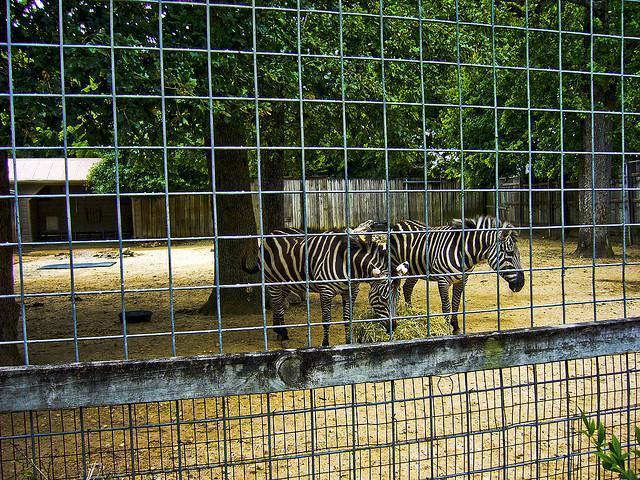How many zebras can you see?
Give a very brief answer. 2. How many bears are in the picture?
Give a very brief answer. 0. 